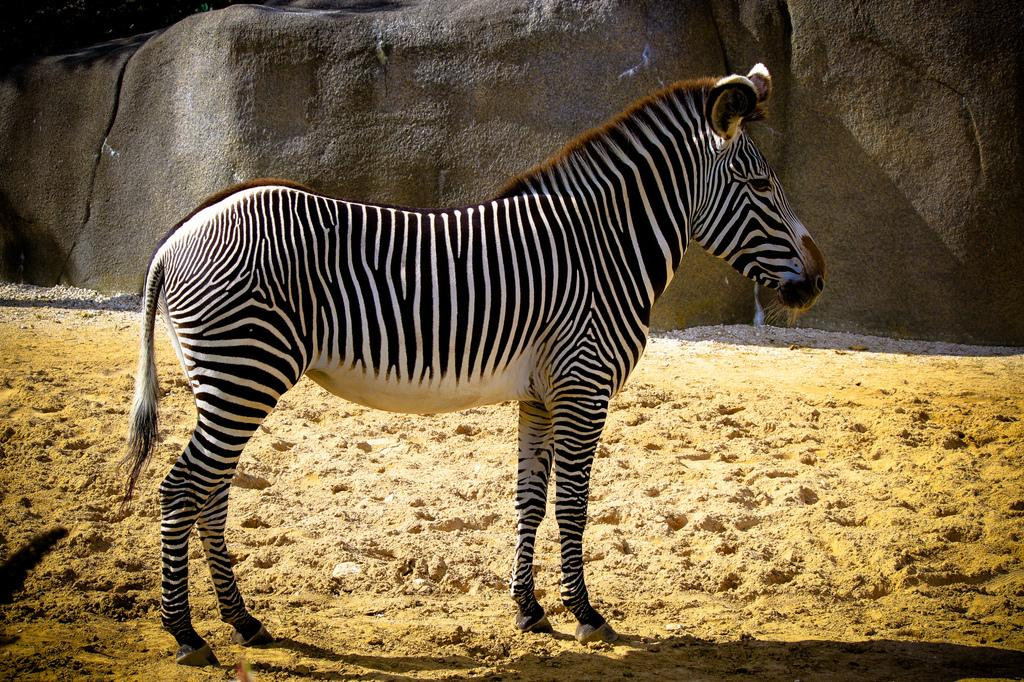What type of creature is in the image? There is an animal in the image. What color is the animal? The animal is in black and white color. Where is the animal located in the image? The animal is on the ground. What can be seen in the background of the image? There is a rock visible in the background of the image. What type of beef is being served on the cover of the book in the image? There is no book or beef present in the image; it features an animal in black and white color on the ground. 